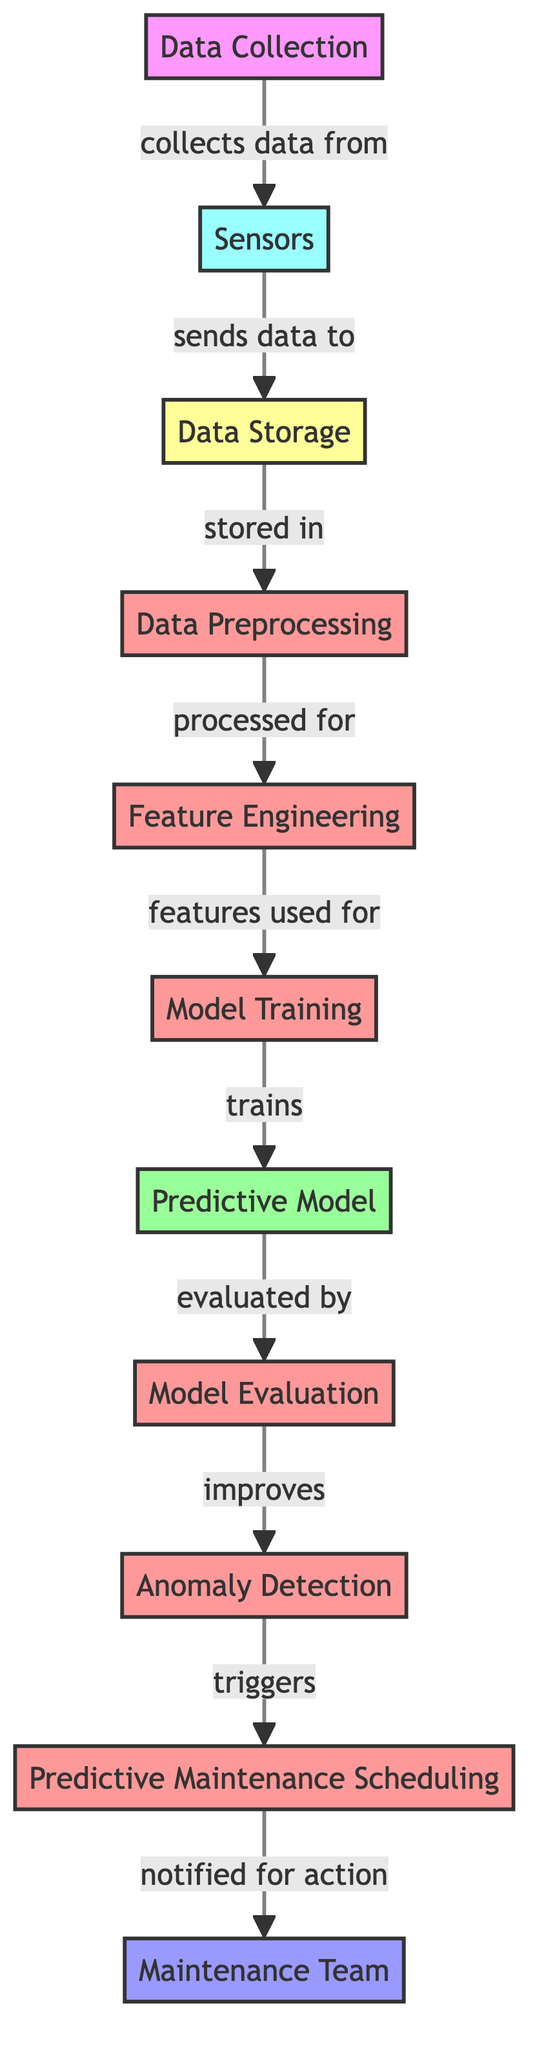What is the first step in the predictive maintenance process? The first step is Data Collection, which is indicated as the starting point of the flowchart leading to the collection of data from sensors.
Answer: Data Collection How many process nodes are in the diagram? The diagram has five process nodes, which include Data Preprocessing, Feature Engineering, Model Training, Model Evaluation, and Anomaly Detection.
Answer: Five What is the relationship between Sensors and Data Storage? Sensors send data to Data Storage, demonstrating the flow of information from one node to another in the diagram.
Answer: Sends data to What component triggers the Predictive Maintenance Scheduling? Anomaly Detection triggers Predictive Maintenance Scheduling, as shown by the directed flow from one node to the next in the diagram.
Answer: Anomaly Detection What comes after Model Evaluation? After Model Evaluation, the process improves Anomaly Detection, indicating that the evaluation contributes to refining the detection mechanism.
Answer: Improves Who is notified after Predictive Maintenance Scheduling? The Maintenance Team is notified for action, as indicated by the final node that receives notifications in the diagram.
Answer: Maintenance Team Explain how features are used in the diagram. Features are used for Model Training, demonstrating that feature engineering contributes to preparing data inputs for the training of the predictive model.
Answer: Model Training What is required for the Predictive Model? The Predictive Model requires training, which is shown by the flow that indicates the necessity of a trained model for predictive maintenance.
Answer: Trains What is the label of the node that comes after Data Storage? The node that follows Data Storage is labeled Data Preprocessing, indicating the next step in the process flow of the diagram.
Answer: Data Preprocessing 